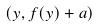Convert formula to latex. <formula><loc_0><loc_0><loc_500><loc_500>( y , f ( y ) + a )</formula> 